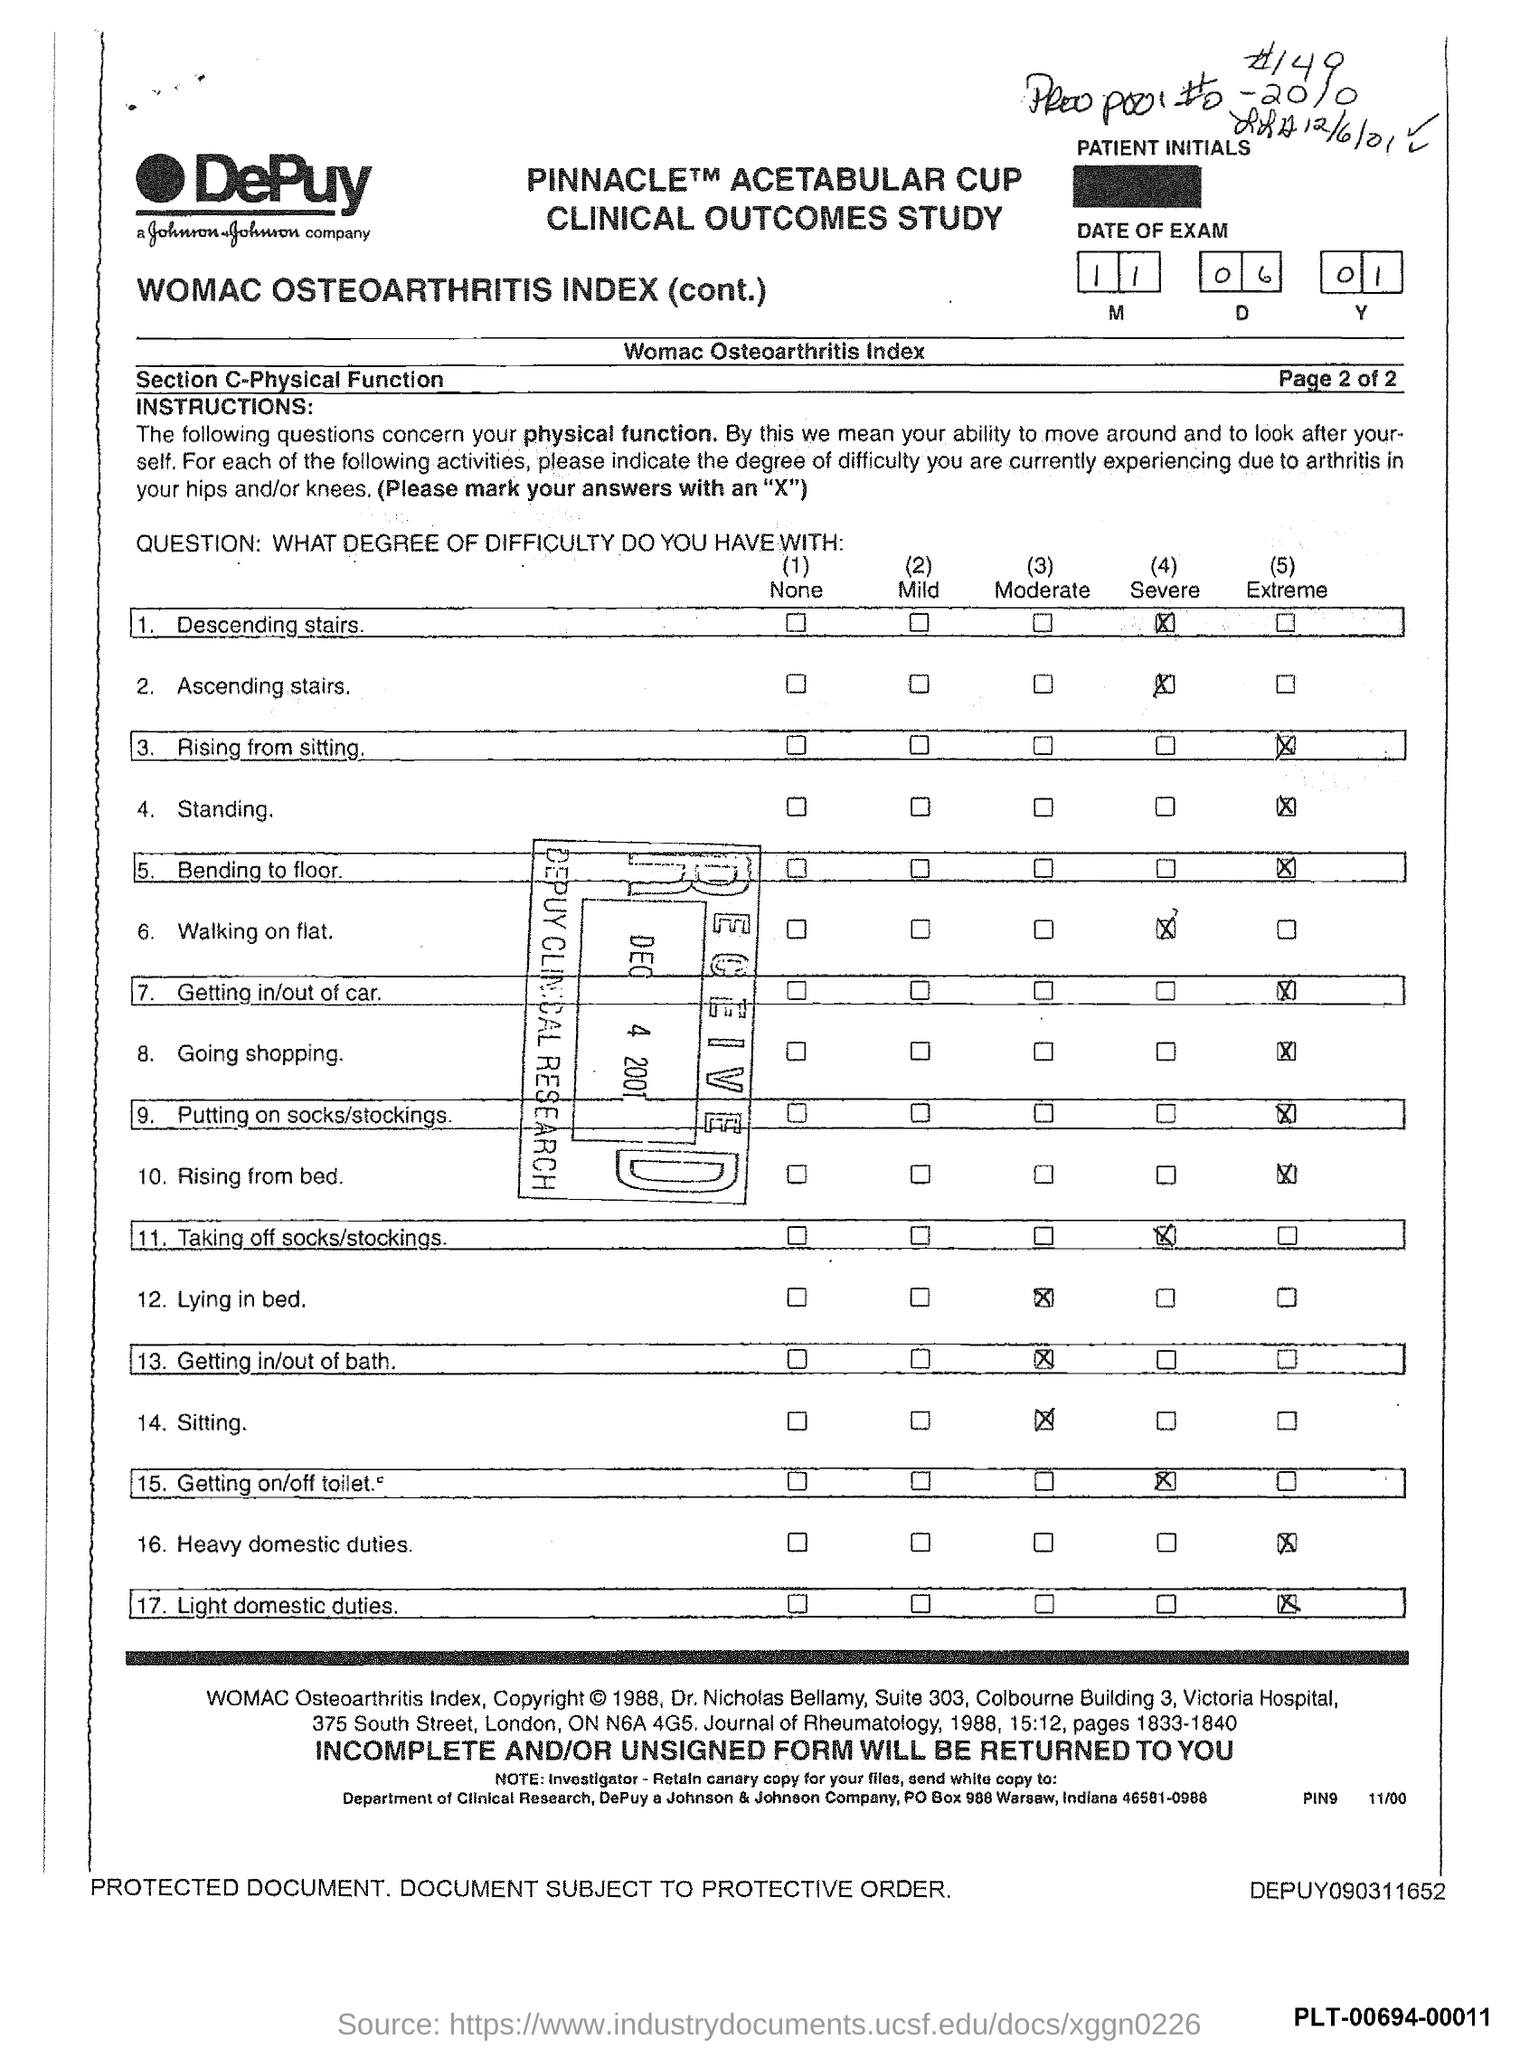What is the po box no. of johnson & johnson company ?
Offer a terse response. 988. In which state is johnson & johnson company located ?
Offer a very short reply. Indiana. 